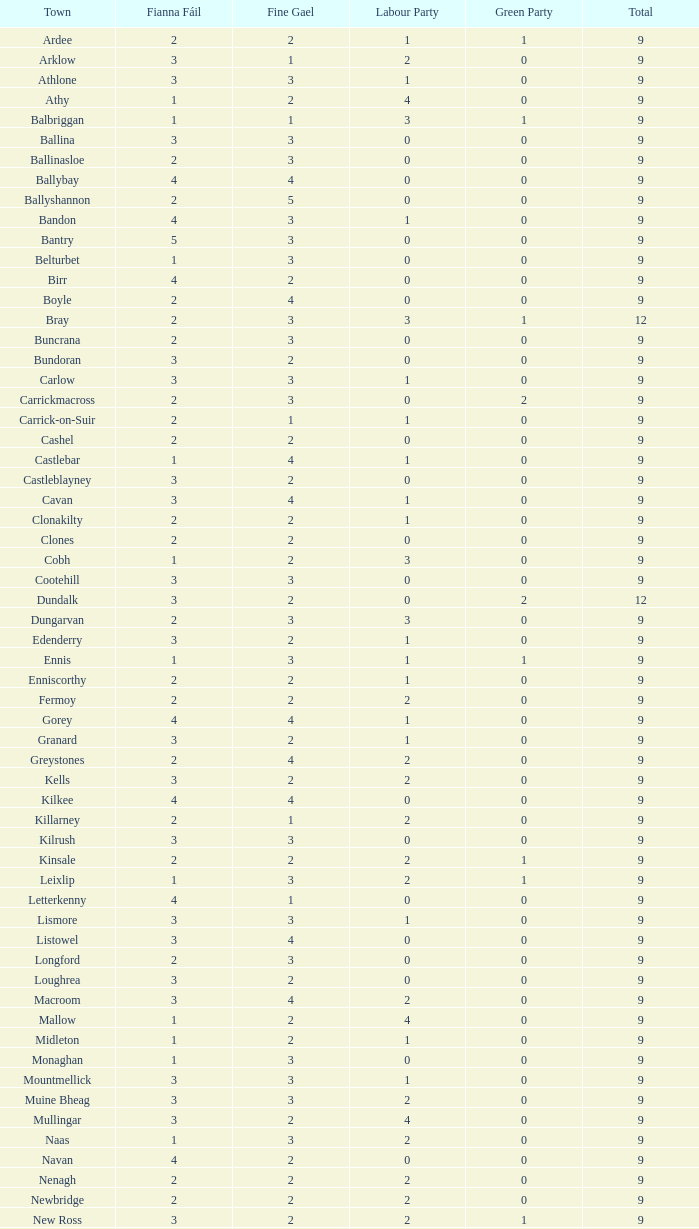How many are in the Labour Party of a Fianna Fail of 3 with a total higher than 9 and more than 2 in the Green Party? None. 